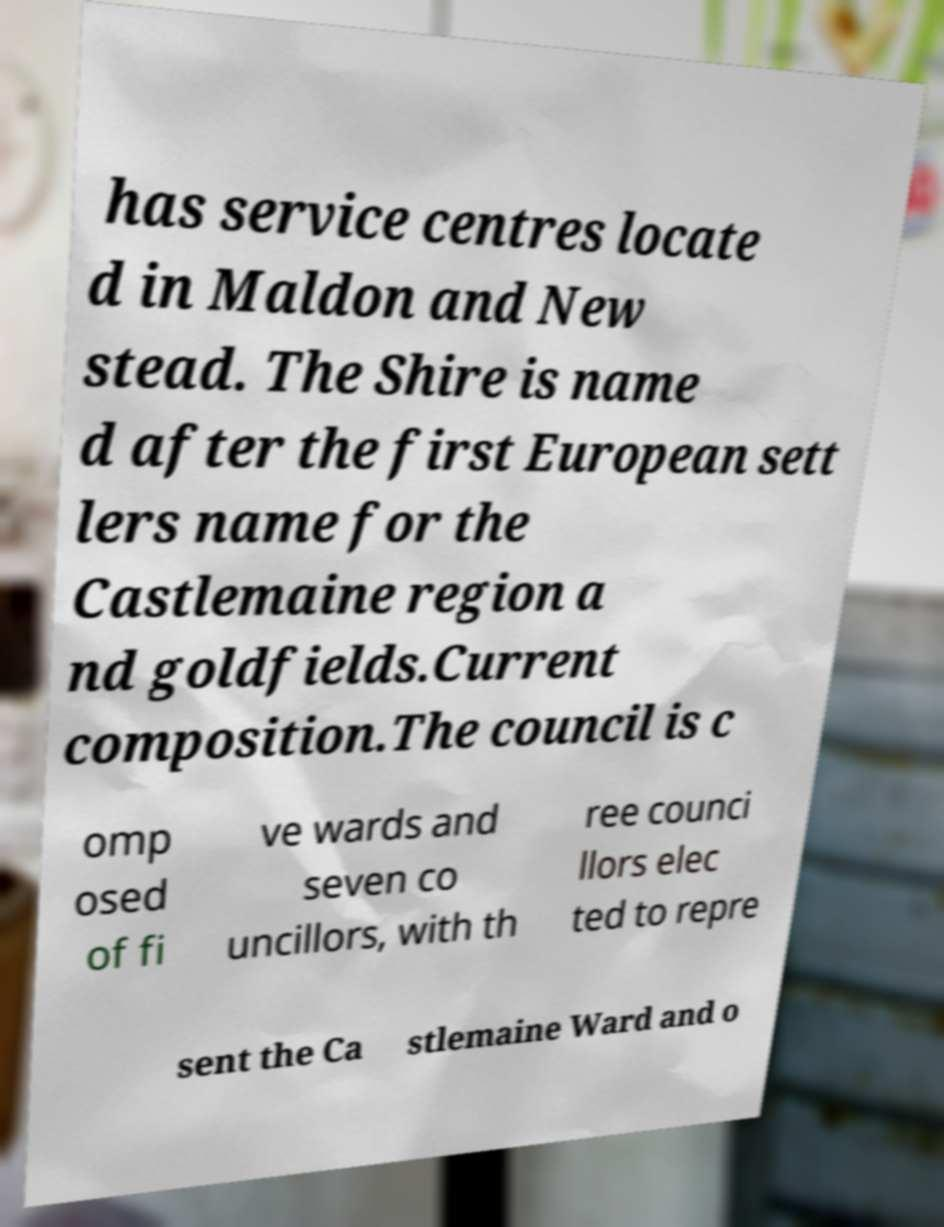What messages or text are displayed in this image? I need them in a readable, typed format. has service centres locate d in Maldon and New stead. The Shire is name d after the first European sett lers name for the Castlemaine region a nd goldfields.Current composition.The council is c omp osed of fi ve wards and seven co uncillors, with th ree counci llors elec ted to repre sent the Ca stlemaine Ward and o 